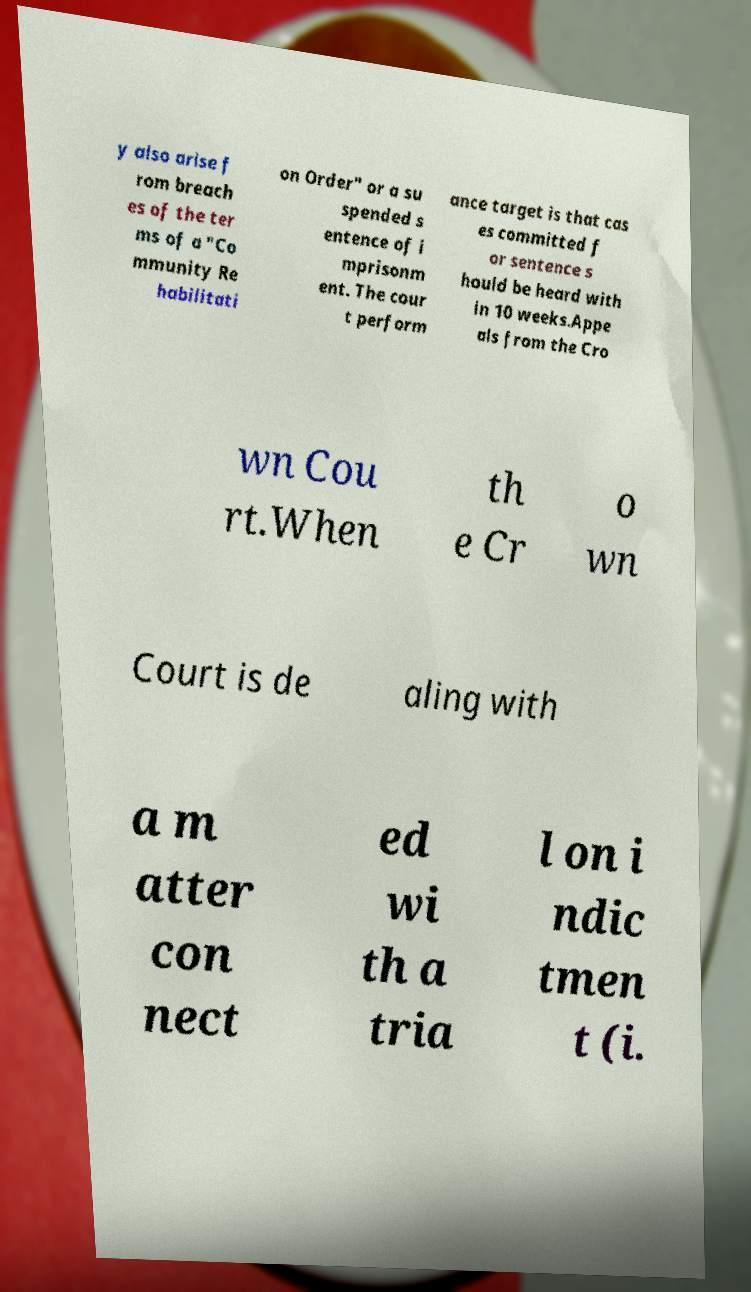Can you accurately transcribe the text from the provided image for me? y also arise f rom breach es of the ter ms of a "Co mmunity Re habilitati on Order" or a su spended s entence of i mprisonm ent. The cour t perform ance target is that cas es committed f or sentence s hould be heard with in 10 weeks.Appe als from the Cro wn Cou rt.When th e Cr o wn Court is de aling with a m atter con nect ed wi th a tria l on i ndic tmen t (i. 